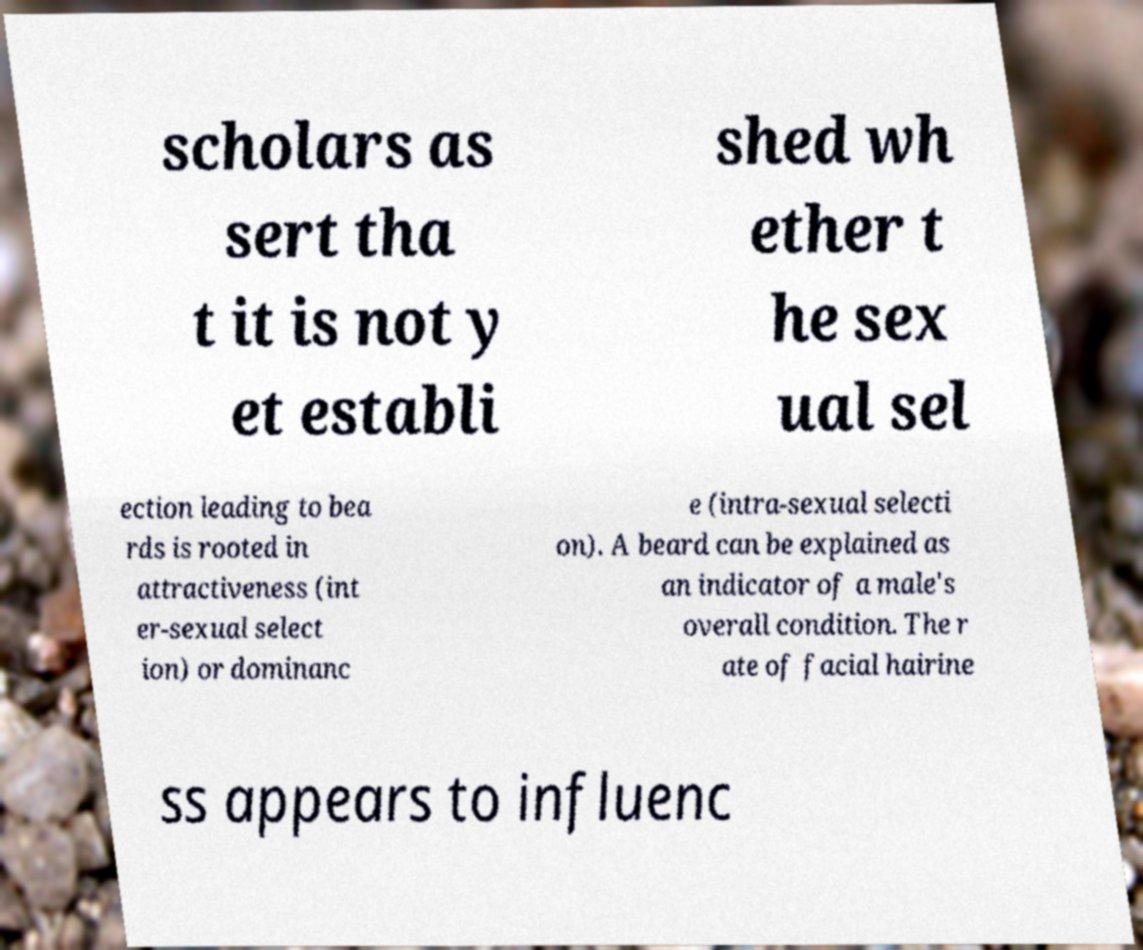What messages or text are displayed in this image? I need them in a readable, typed format. scholars as sert tha t it is not y et establi shed wh ether t he sex ual sel ection leading to bea rds is rooted in attractiveness (int er-sexual select ion) or dominanc e (intra-sexual selecti on). A beard can be explained as an indicator of a male's overall condition. The r ate of facial hairine ss appears to influenc 